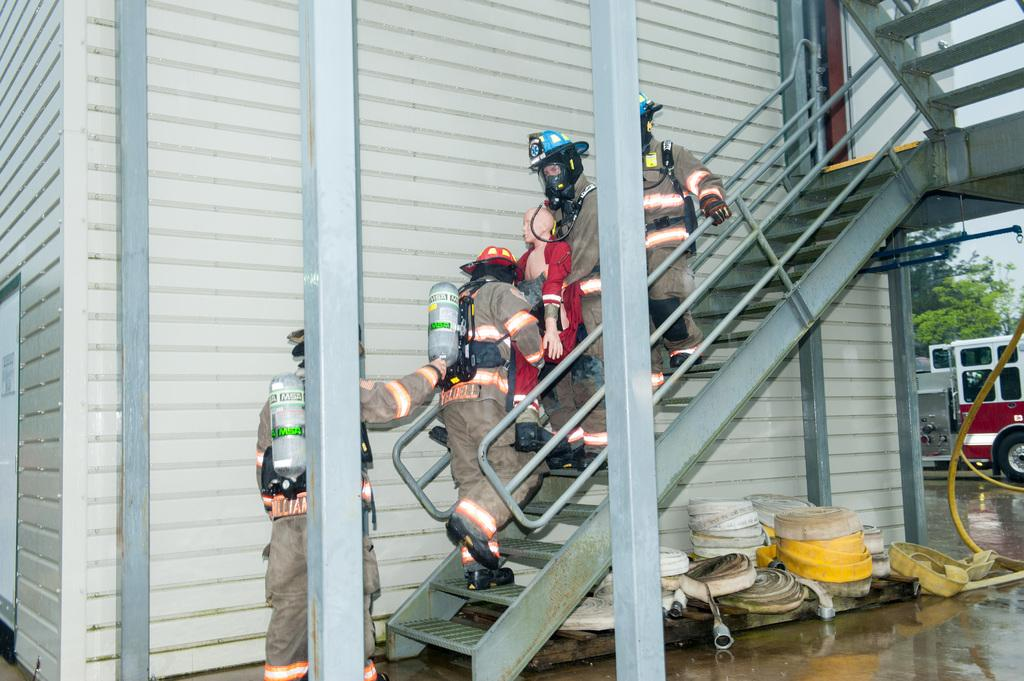What are the people in the image doing? People are using stairs in the image. Can you describe the position of the man in the image? A man is standing in the image. What type of object can be seen in the image besides the stairs and the man? There is a vehicle in the image. What natural element is present in the image? There is a tree in the image. How many divisions can be seen in the image? There is no mention of divisions in the image, so it cannot be determined from the image. 